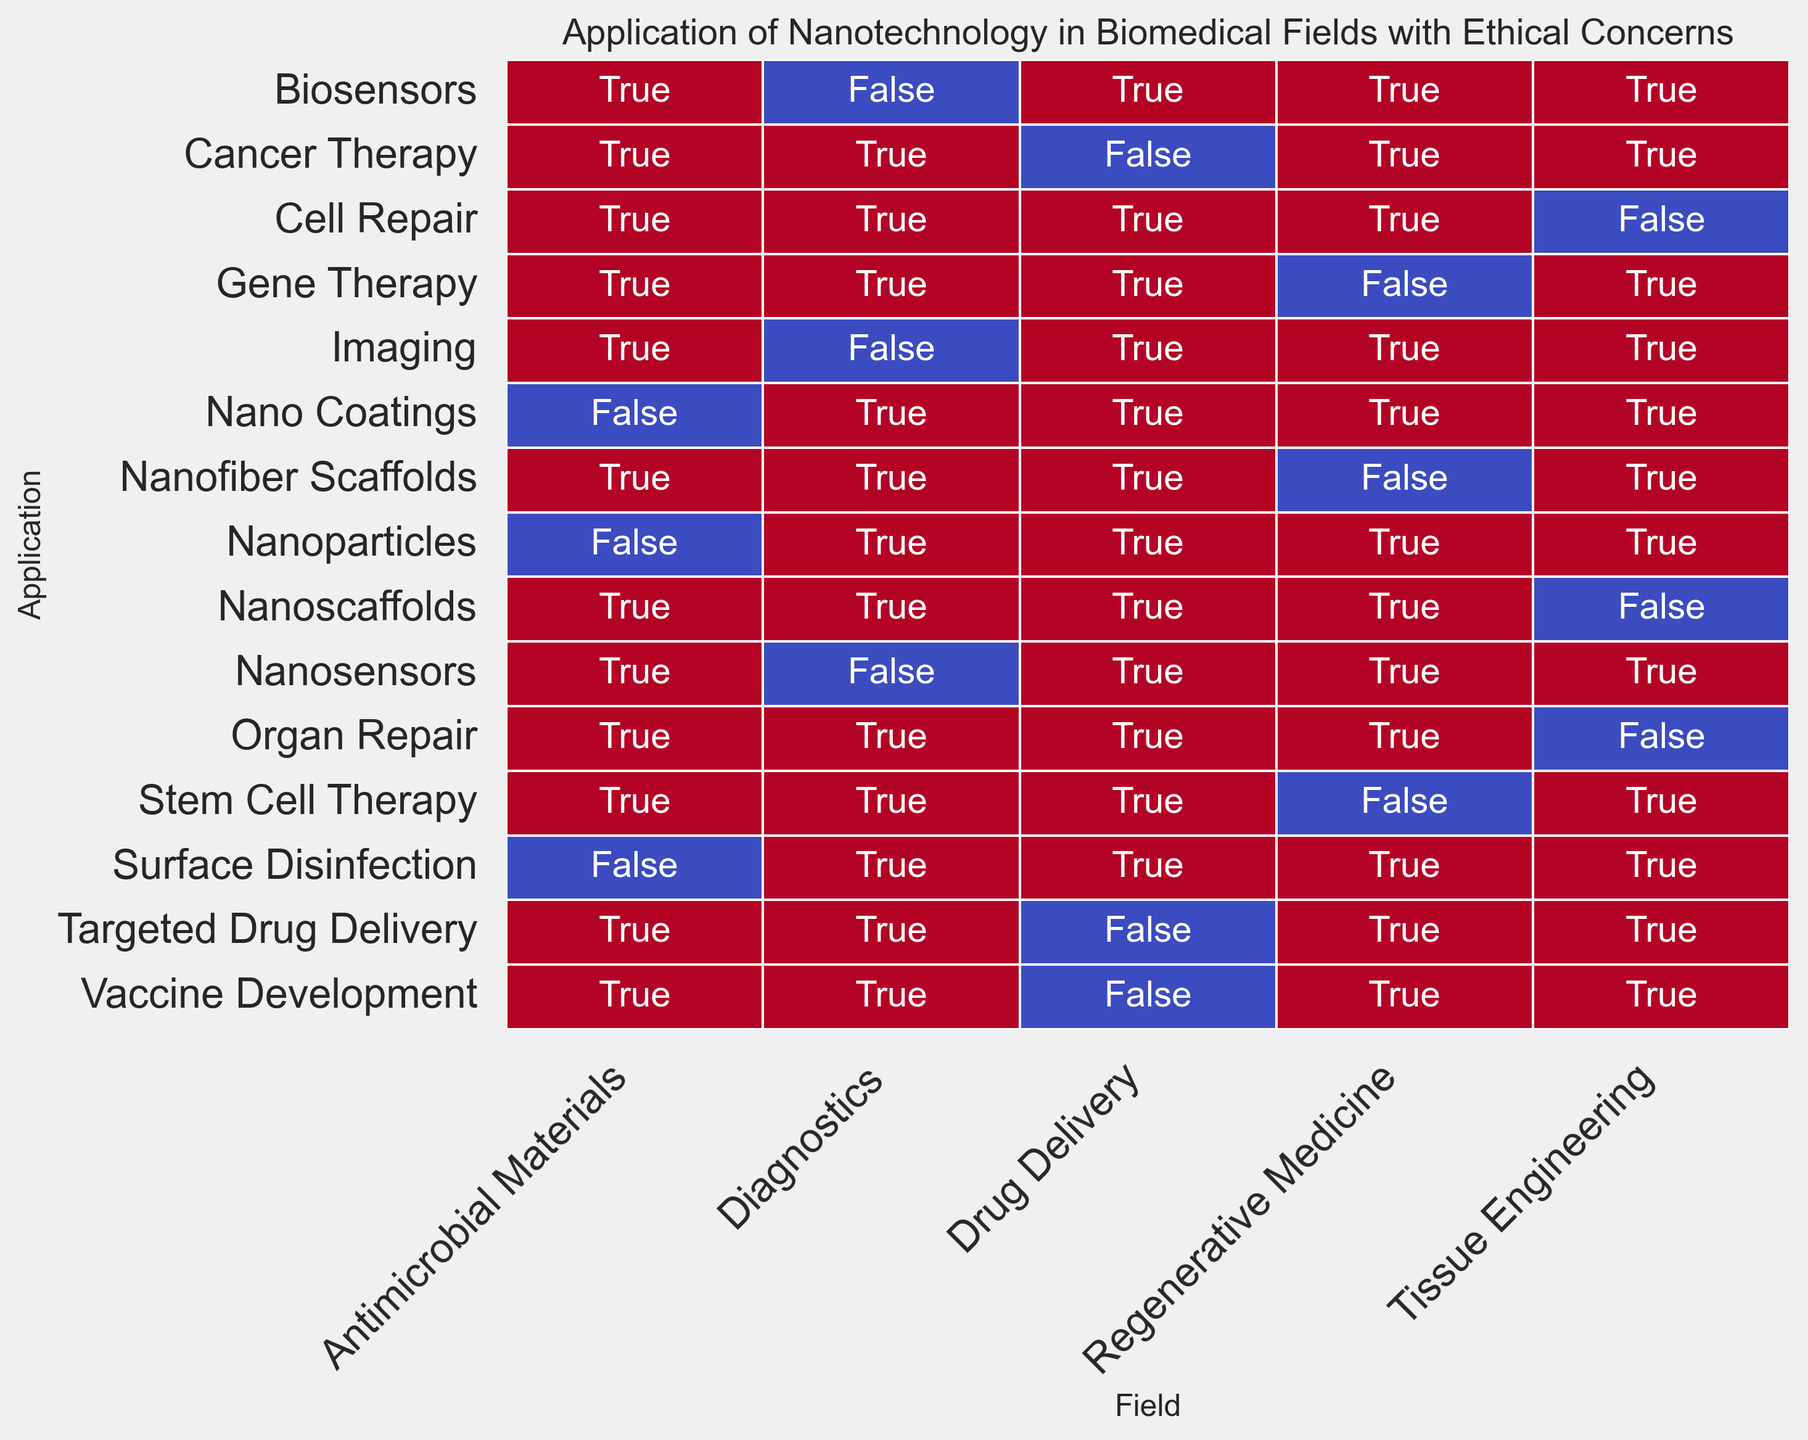What is the ethical concern associated with the application of nanosensors in diagnostics? The heatmap shows that for the application of nanosensors under the field of diagnostics, the ethical concern is annotated as "Privacy and data security".
Answer: Privacy and data security Which biomedical field has "Informed consent in clinical trials" as an ethical concern? Looking at the heatmap, "Informed consent in clinical trials" is listed as an ethical concern under the Drug Delivery field with the application of Cancer Therapy.
Answer: Drug Delivery How many biomedical fields are represented in the heatmap? Observing the x-axis labels of the heatmap, there are 5 different fields: Drug Delivery, Diagnostics, Tissue Engineering, Regenerative Medicine, and Antimicrobial Materials.
Answer: 5 Which application under the Tissue Engineering field has "Equitable access" as an ethical concern? For the Tissue Engineering field, "Equitable access" is the ethical concern related to the application of Organ Repair, as indicated in the heatmap.
Answer: Organ Repair Are there any applications related to "Effect on non-target organisms"? If yes, in which field do they belong? The heatmap shows that "Effect on non-target organisms" is an ethical concern under the Antimicrobial Materials field with the application of Surface Disinfection.
Answer: Yes, Antimicrobial Materials Which field has the ethical concern of "Resource allocation" and in which application is it observed? In the heatmap, "Resource allocation" is under the Regenerative Medicine field and is associated with Stem Cell Therapy.
Answer: Regenerative Medicine, Stem Cell Therapy Compare the number of ethical concerns related to safety and security between the fields of Diagnostics and Drug Delivery. Which field has more such concerns? In the Diagnostics field, there are concerns like "Privacy and data security". In Drug Delivery, there are "Safety of nanoparticles" and "Biodistribution and long-term effects". Drug Delivery has more safety and security-related concerns (2) compared to Diagnostics (1).
Answer: Drug Delivery Which application under the Regenerative Medicine field is associated with "Genetic modification ethics"? According to the heatmap, the application related to "Genetic modification ethics" in the Regenerative Medicine field is Gene Therapy.
Answer: Gene Therapy How many applications under the Antimicrobial Materials field are represented, and what are their associated ethical concerns? By counting the annotations under the Antimicrobial Materials field in the heatmap, there are 3 applications: Nano Coatings ("Environmental impact"), Nanoparticles ("Antibiotic resistance"), and Surface Disinfection ("Effect on non-target organisms").
Answer: 3, Environmental impact, Antibiotic resistance, Effect on non-target organisms 